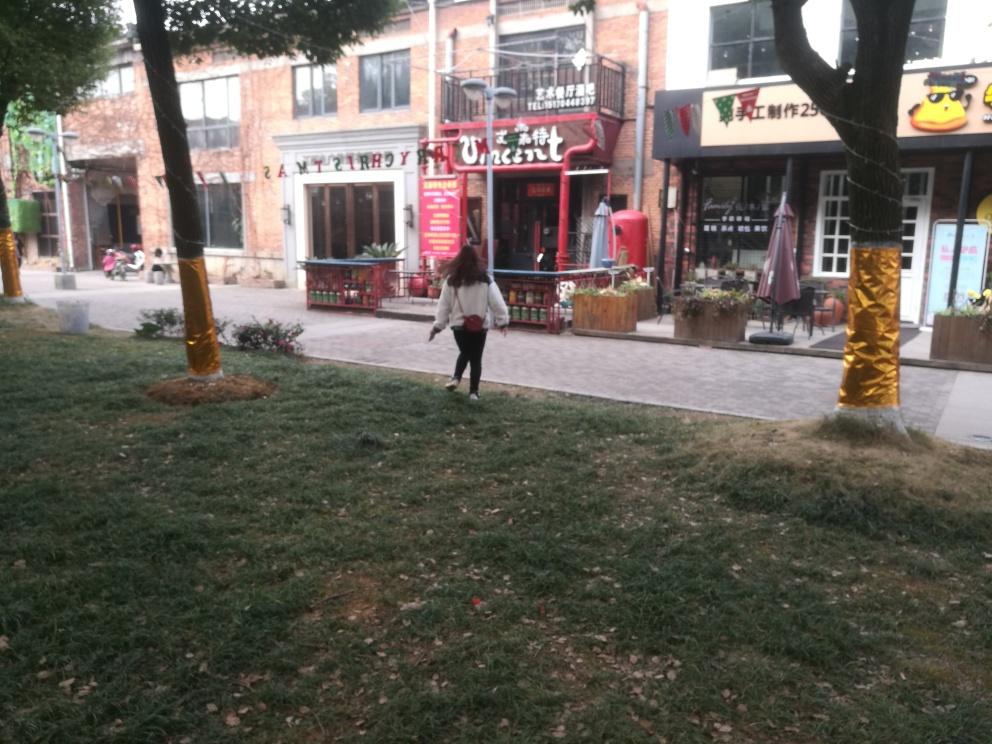Is the area crowded? No, the area is not crowded. There is only one person visible in the image, which implies that the photo was taken during a time of low pedestrian traffic or in a less crowded area. 